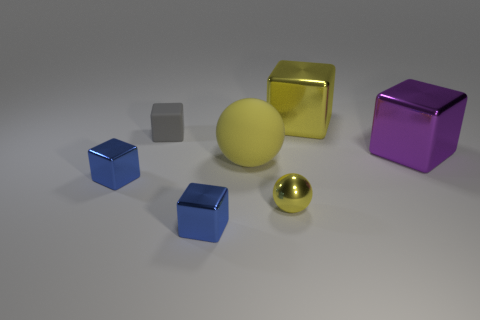How many tiny metal objects are left of the tiny shiny block that is behind the small blue metal thing that is in front of the shiny ball?
Ensure brevity in your answer.  0. What size is the other thing that is the same material as the gray thing?
Give a very brief answer. Large. How many large shiny cubes are the same color as the tiny sphere?
Your answer should be compact. 1. Do the yellow metallic object that is on the left side of the yellow block and the tiny gray matte object have the same size?
Make the answer very short. Yes. What is the color of the block that is both to the left of the small yellow object and behind the yellow matte thing?
Provide a succinct answer. Gray. How many objects are big yellow metal cubes or tiny objects that are left of the matte sphere?
Provide a succinct answer. 4. There is a tiny gray thing that is on the left side of the big cube to the left of the large cube that is in front of the yellow block; what is it made of?
Ensure brevity in your answer.  Rubber. Is there any other thing that has the same material as the big yellow sphere?
Your answer should be very brief. Yes. Do the tiny object behind the large purple thing and the big ball have the same color?
Make the answer very short. No. What number of yellow things are either tiny shiny objects or metallic cubes?
Provide a short and direct response. 2. 